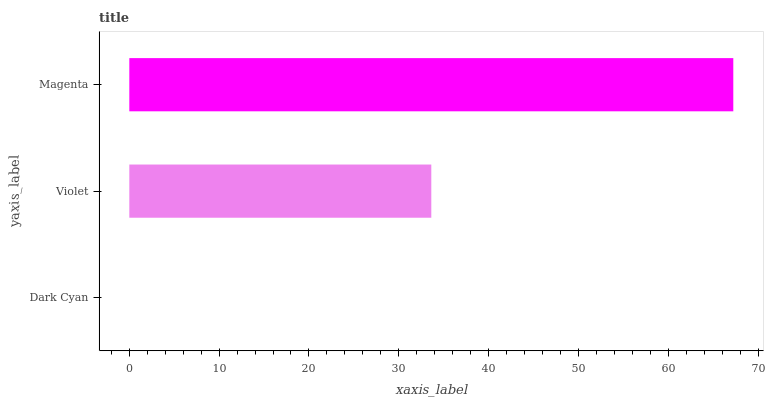Is Dark Cyan the minimum?
Answer yes or no. Yes. Is Magenta the maximum?
Answer yes or no. Yes. Is Violet the minimum?
Answer yes or no. No. Is Violet the maximum?
Answer yes or no. No. Is Violet greater than Dark Cyan?
Answer yes or no. Yes. Is Dark Cyan less than Violet?
Answer yes or no. Yes. Is Dark Cyan greater than Violet?
Answer yes or no. No. Is Violet less than Dark Cyan?
Answer yes or no. No. Is Violet the high median?
Answer yes or no. Yes. Is Violet the low median?
Answer yes or no. Yes. Is Magenta the high median?
Answer yes or no. No. Is Dark Cyan the low median?
Answer yes or no. No. 